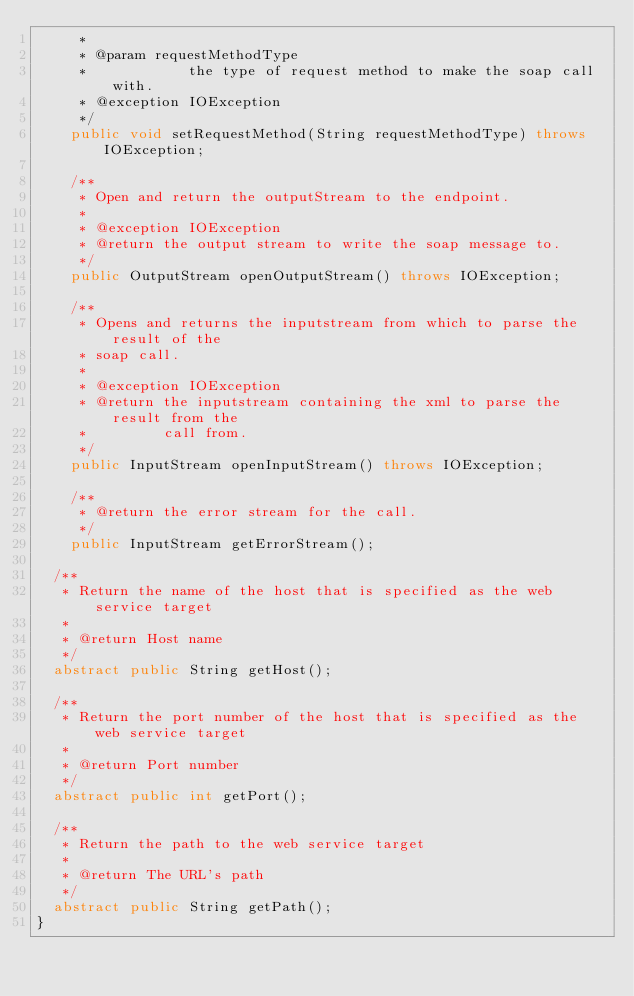<code> <loc_0><loc_0><loc_500><loc_500><_Java_>     * 
     * @param requestMethodType
     *            the type of request method to make the soap call with.
     * @exception IOException
     */
    public void setRequestMethod(String requestMethodType) throws IOException;
    
    /**
     * Open and return the outputStream to the endpoint.
     * 
     * @exception IOException
     * @return the output stream to write the soap message to.
     */
    public OutputStream openOutputStream() throws IOException;

    /**
     * Opens and returns the inputstream from which to parse the result of the
     * soap call.
     * 
     * @exception IOException
     * @return the inputstream containing the xml to parse the result from the
     *         call from.
     */
    public InputStream openInputStream() throws IOException;

    /**
     * @return the error stream for the call.
     */
    public InputStream getErrorStream();

	/**
	 * Return the name of the host that is specified as the web service target
	 * 
	 * @return Host name
	 */
	abstract public String getHost();

	/**
	 * Return the port number of the host that is specified as the web service target
	 * 
	 * @return Port number
	 */
	abstract public int getPort();

	/**
	 * Return the path to the web service target
	 * 
	 * @return The URL's path
	 */
	abstract public String getPath();
}
</code> 